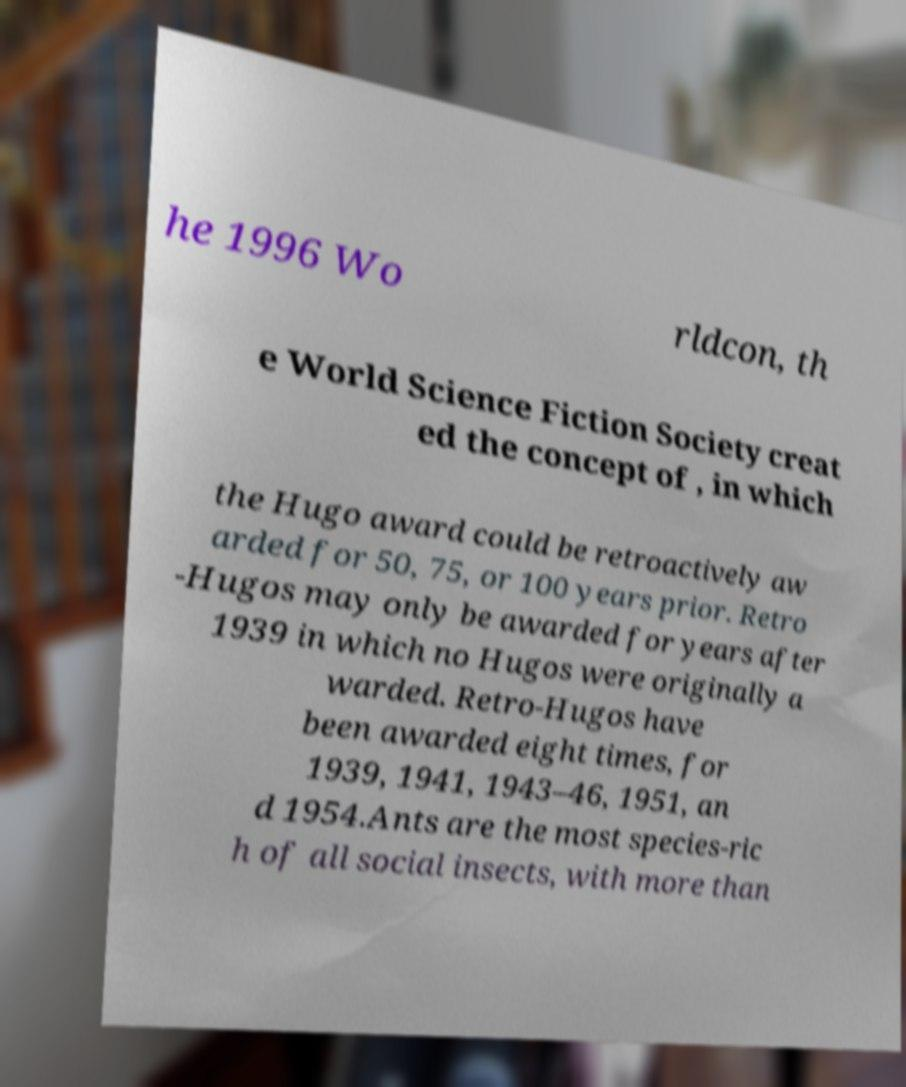I need the written content from this picture converted into text. Can you do that? he 1996 Wo rldcon, th e World Science Fiction Society creat ed the concept of , in which the Hugo award could be retroactively aw arded for 50, 75, or 100 years prior. Retro -Hugos may only be awarded for years after 1939 in which no Hugos were originally a warded. Retro-Hugos have been awarded eight times, for 1939, 1941, 1943–46, 1951, an d 1954.Ants are the most species-ric h of all social insects, with more than 